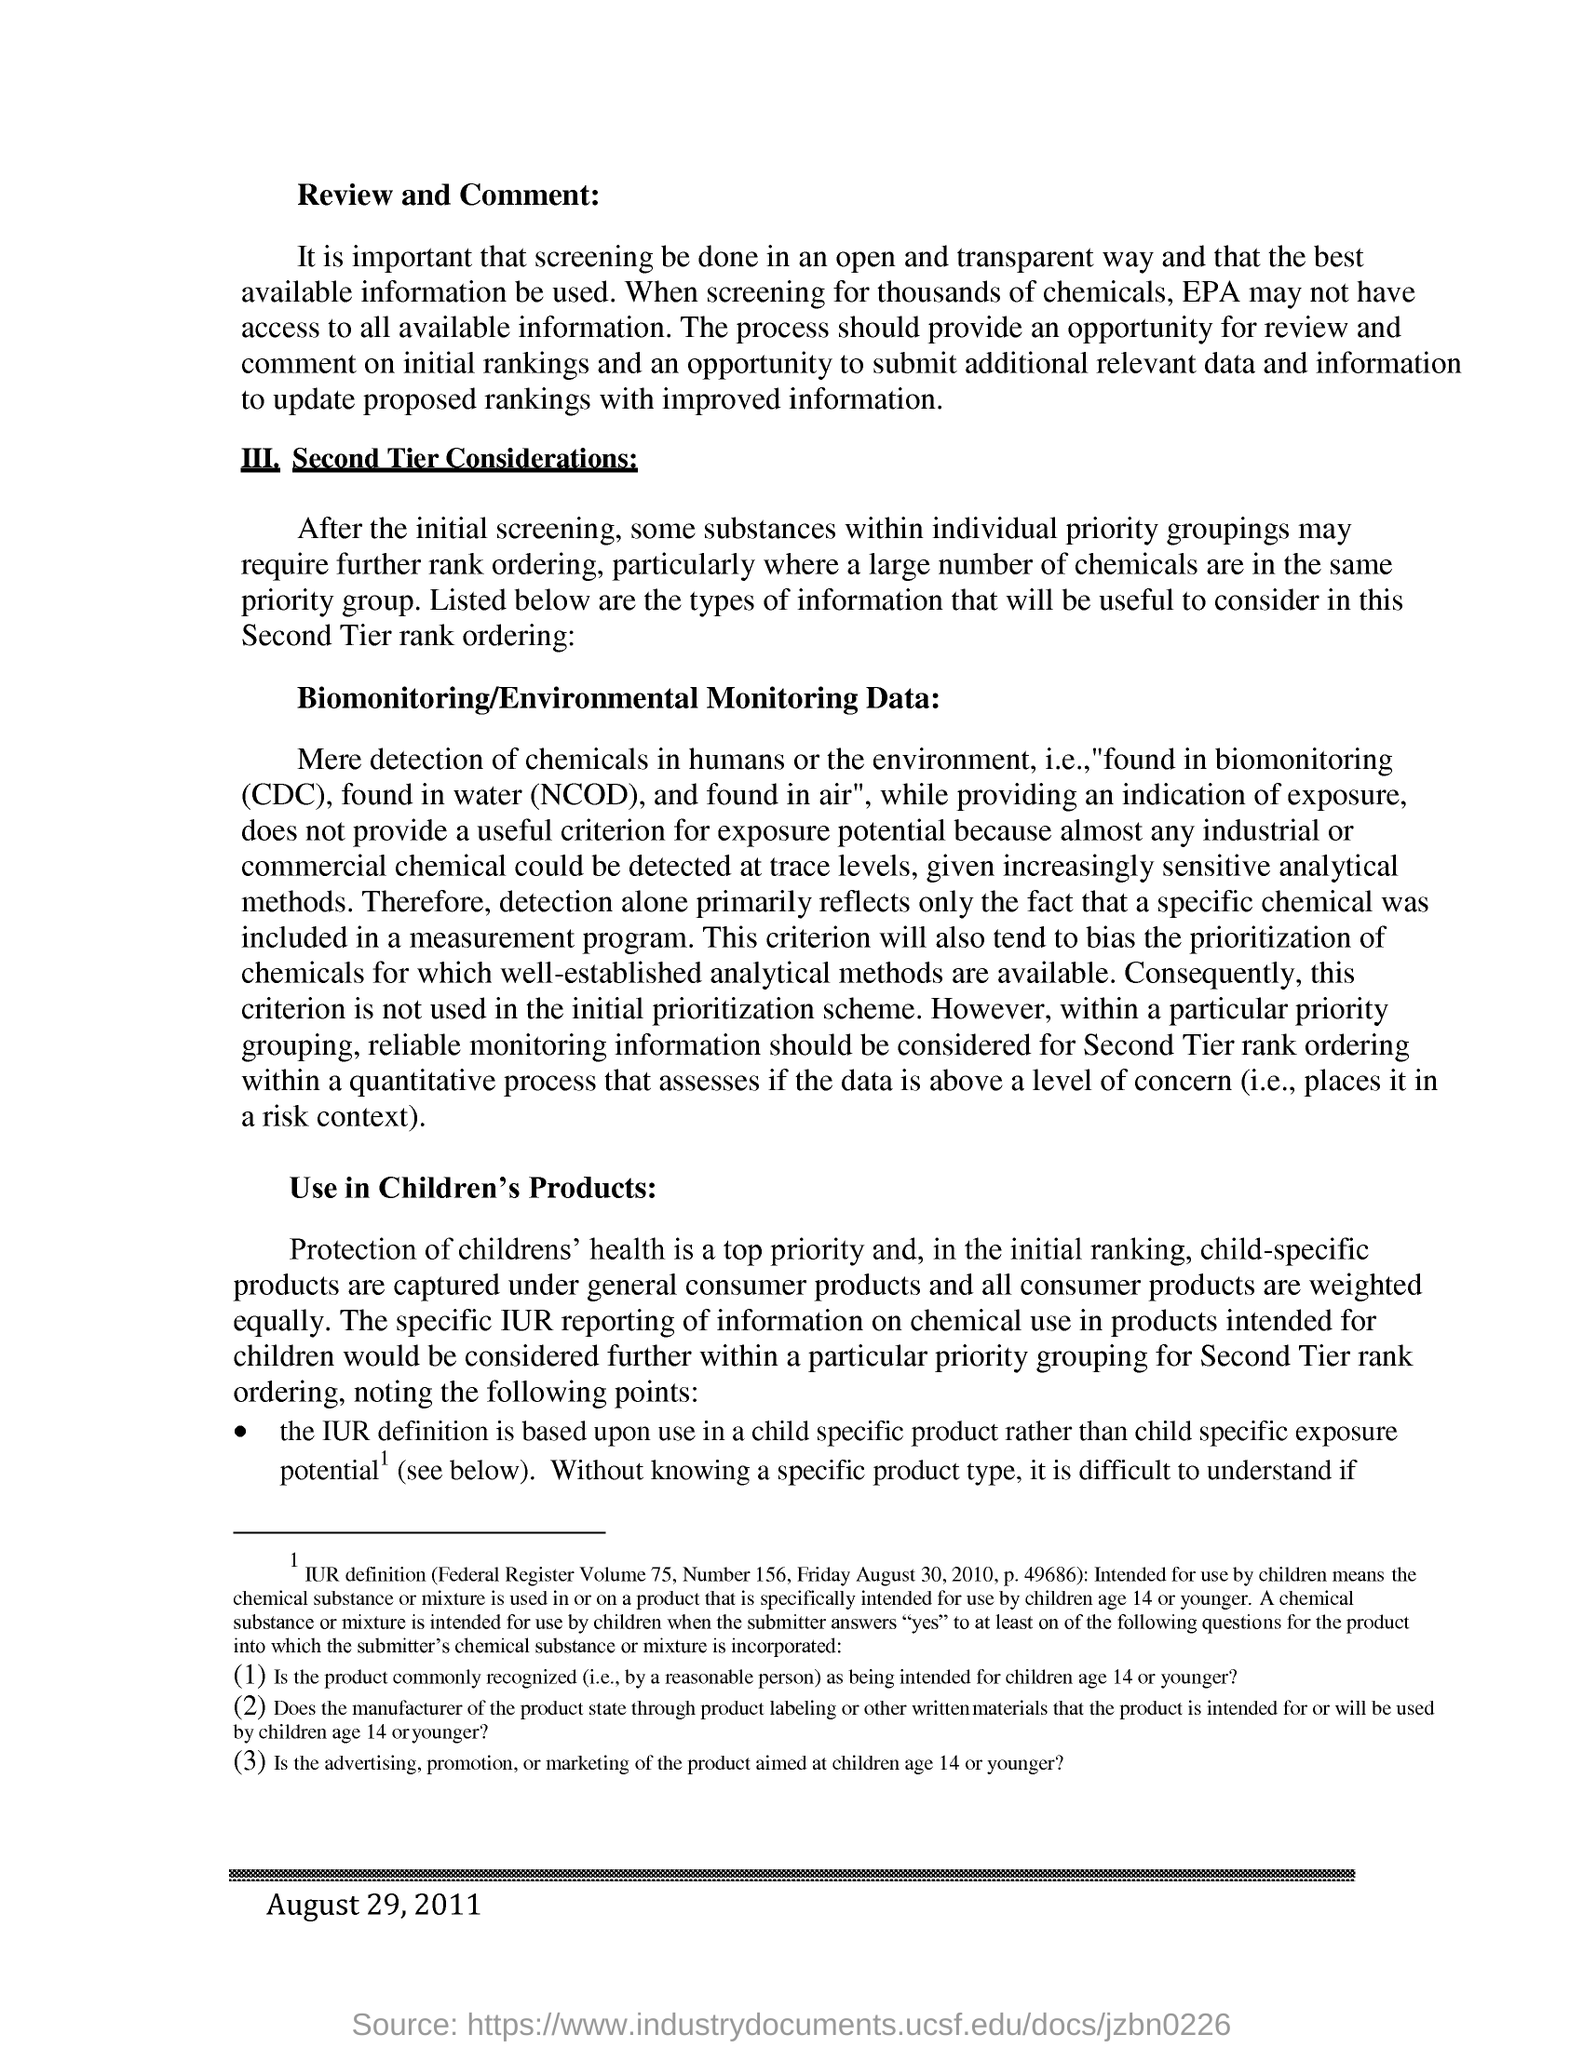What is the date given at the footer?
Provide a short and direct response. August 29, 2011. 